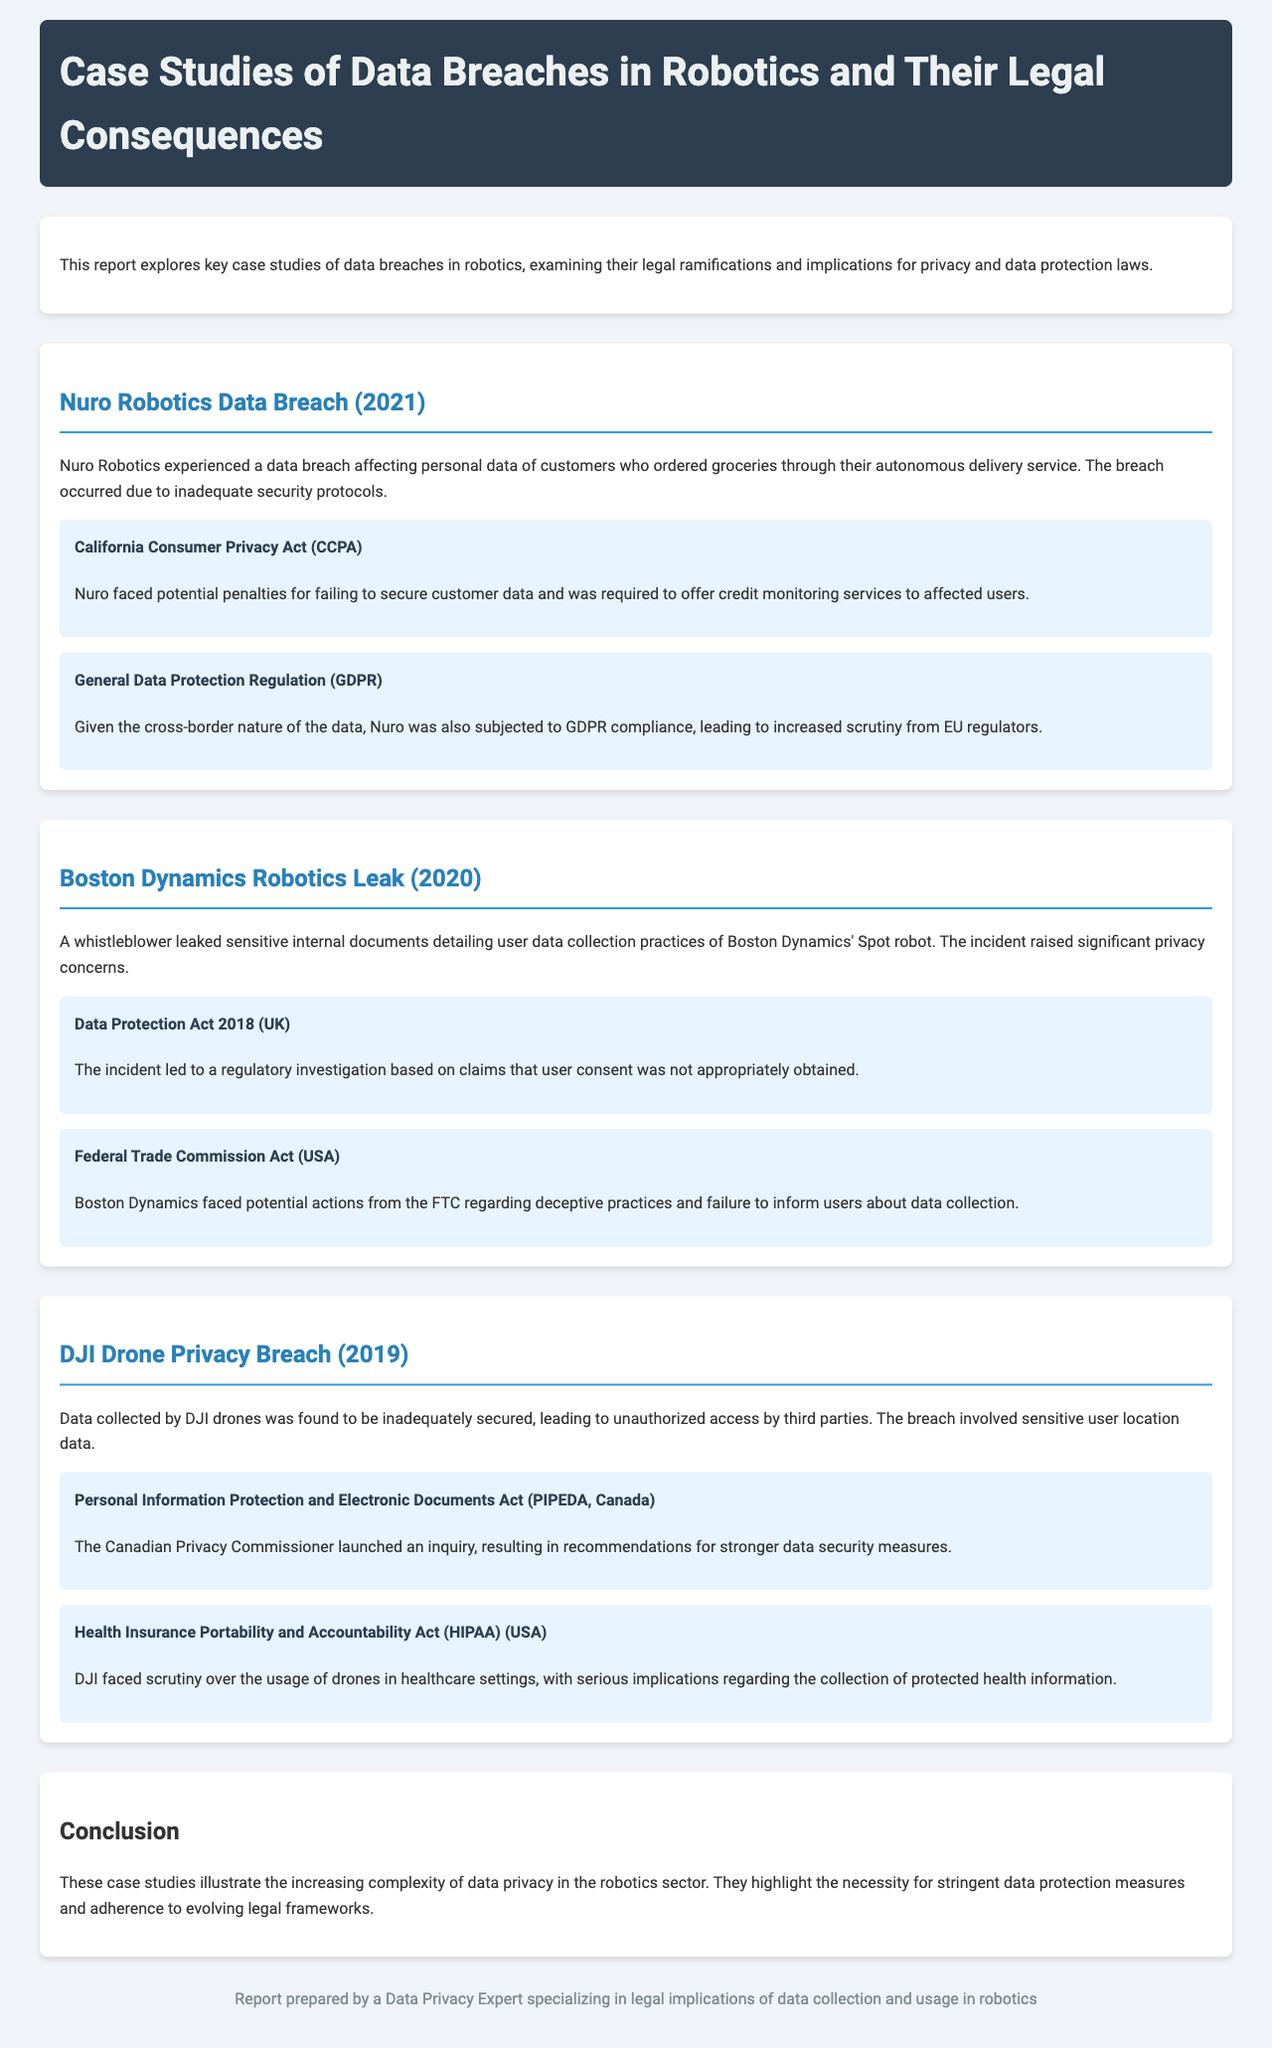What was the year of the Nuro Robotics data breach? The document states that the Nuro Robotics data breach occurred in 2021.
Answer: 2021 What is one legal implication related to the DJI Drone Privacy Breach? The document mentions that the Canadian Privacy Commissioner launched an inquiry under PIPEDA for the DJI Drone Privacy Breach.
Answer: PIPEDA Which company faced scrutiny under the General Data Protection Regulation? Nuro Robotics, due to the cross-border nature of their data handling.
Answer: Nuro Robotics What was a key issue in the Boston Dynamics Robotics Leak? The leak involved inadequate user consent regarding data collection practices.
Answer: User consent What consequence did Nuro Robotics face for customer data breach? Nuro was required to offer credit monitoring services to affected users.
Answer: Credit monitoring services 